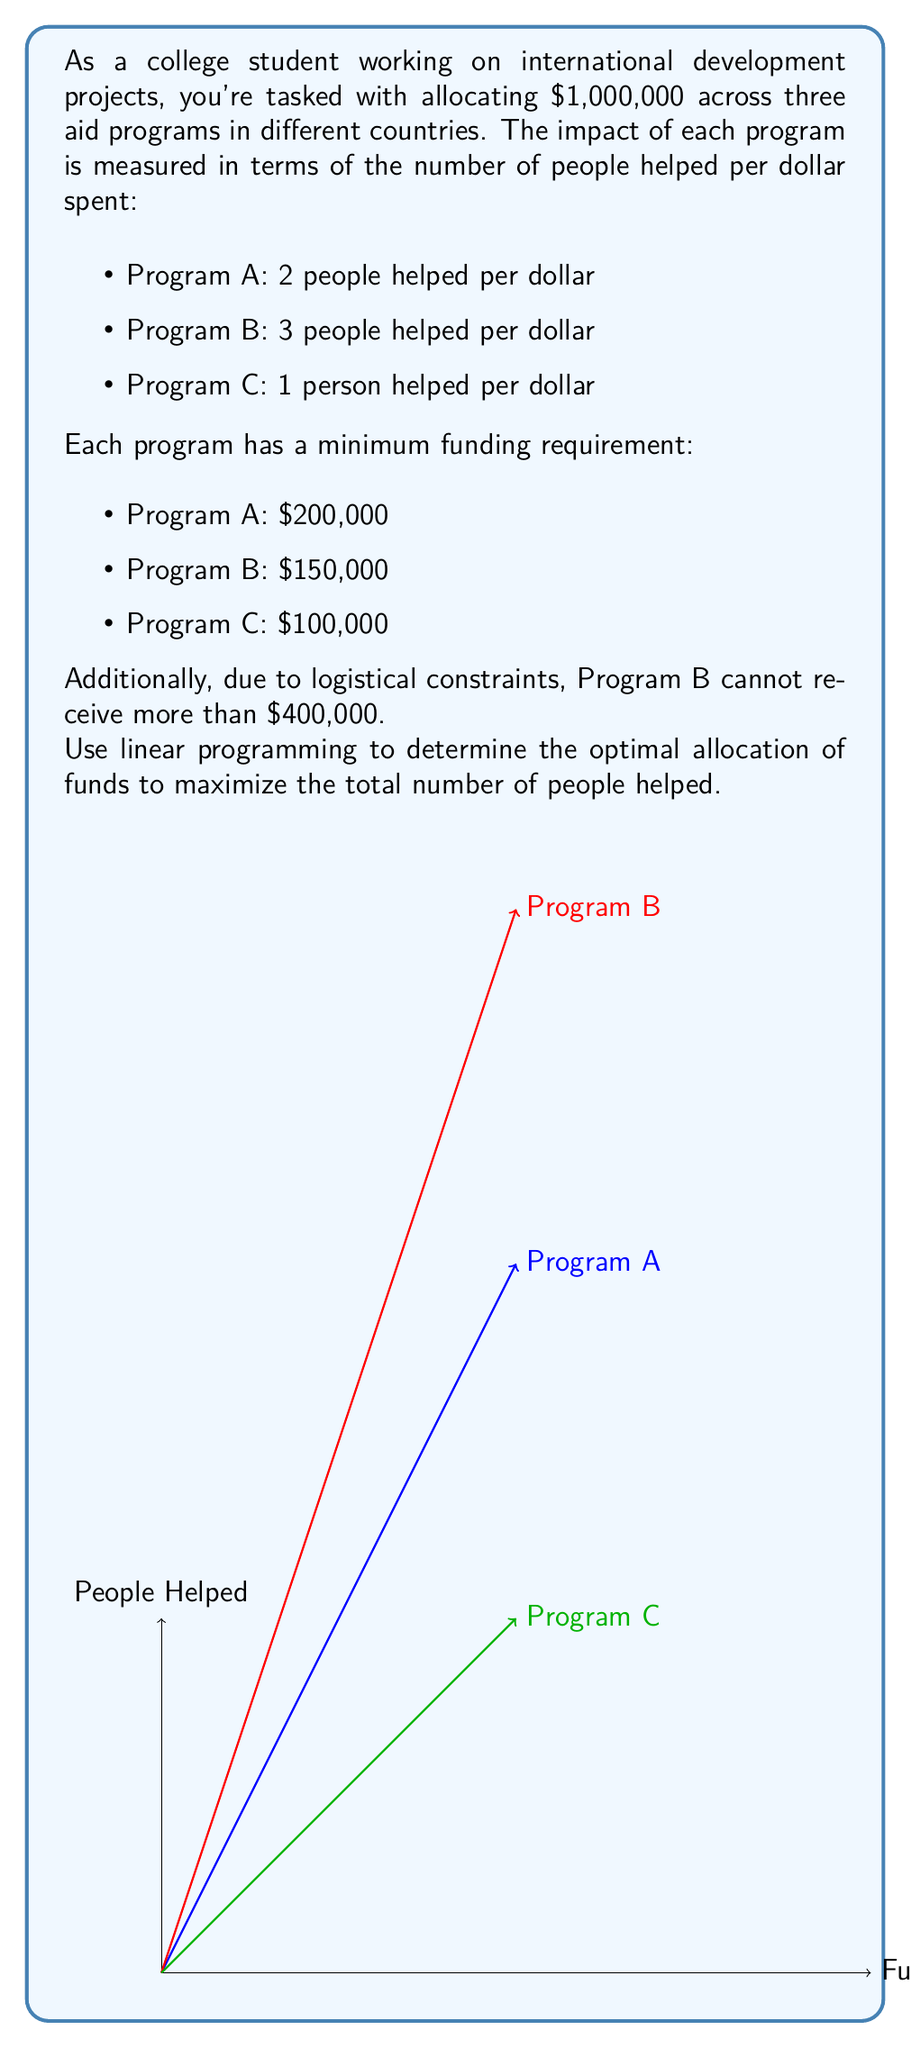Give your solution to this math problem. Let's solve this step-by-step using linear programming:

1) Define variables:
   Let $x_A$, $x_B$, and $x_C$ be the amounts allocated to Programs A, B, and C respectively.

2) Objective function:
   Maximize $Z = 2x_A + 3x_B + x_C$ (total people helped)

3) Constraints:
   $x_A + x_B + x_C \leq 1,000,000$ (total budget)
   $x_A \geq 200,000$ (Program A minimum)
   $x_B \geq 150,000$ (Program B minimum)
   $x_C \geq 100,000$ (Program C minimum)
   $x_B \leq 400,000$ (Program B maximum)

4) Non-negativity:
   $x_A, x_B, x_C \geq 0$

5) Solve using the simplex method or a linear programming solver:
   The optimal solution is:
   $x_A = 450,000$
   $x_B = 400,000$
   $x_C = 150,000$

6) Calculate the maximum number of people helped:
   $Z = 2(450,000) + 3(400,000) + 1(150,000) = 2,150,000$

Therefore, the optimal allocation is to assign $450,000 to Program A, $400,000 to Program B, and $150,000 to Program C, which will help a total of 2,150,000 people.
Answer: Program A: $450,000; Program B: $400,000; Program C: $150,000; Total people helped: 2,150,000 